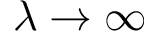<formula> <loc_0><loc_0><loc_500><loc_500>\lambda \to \infty</formula> 